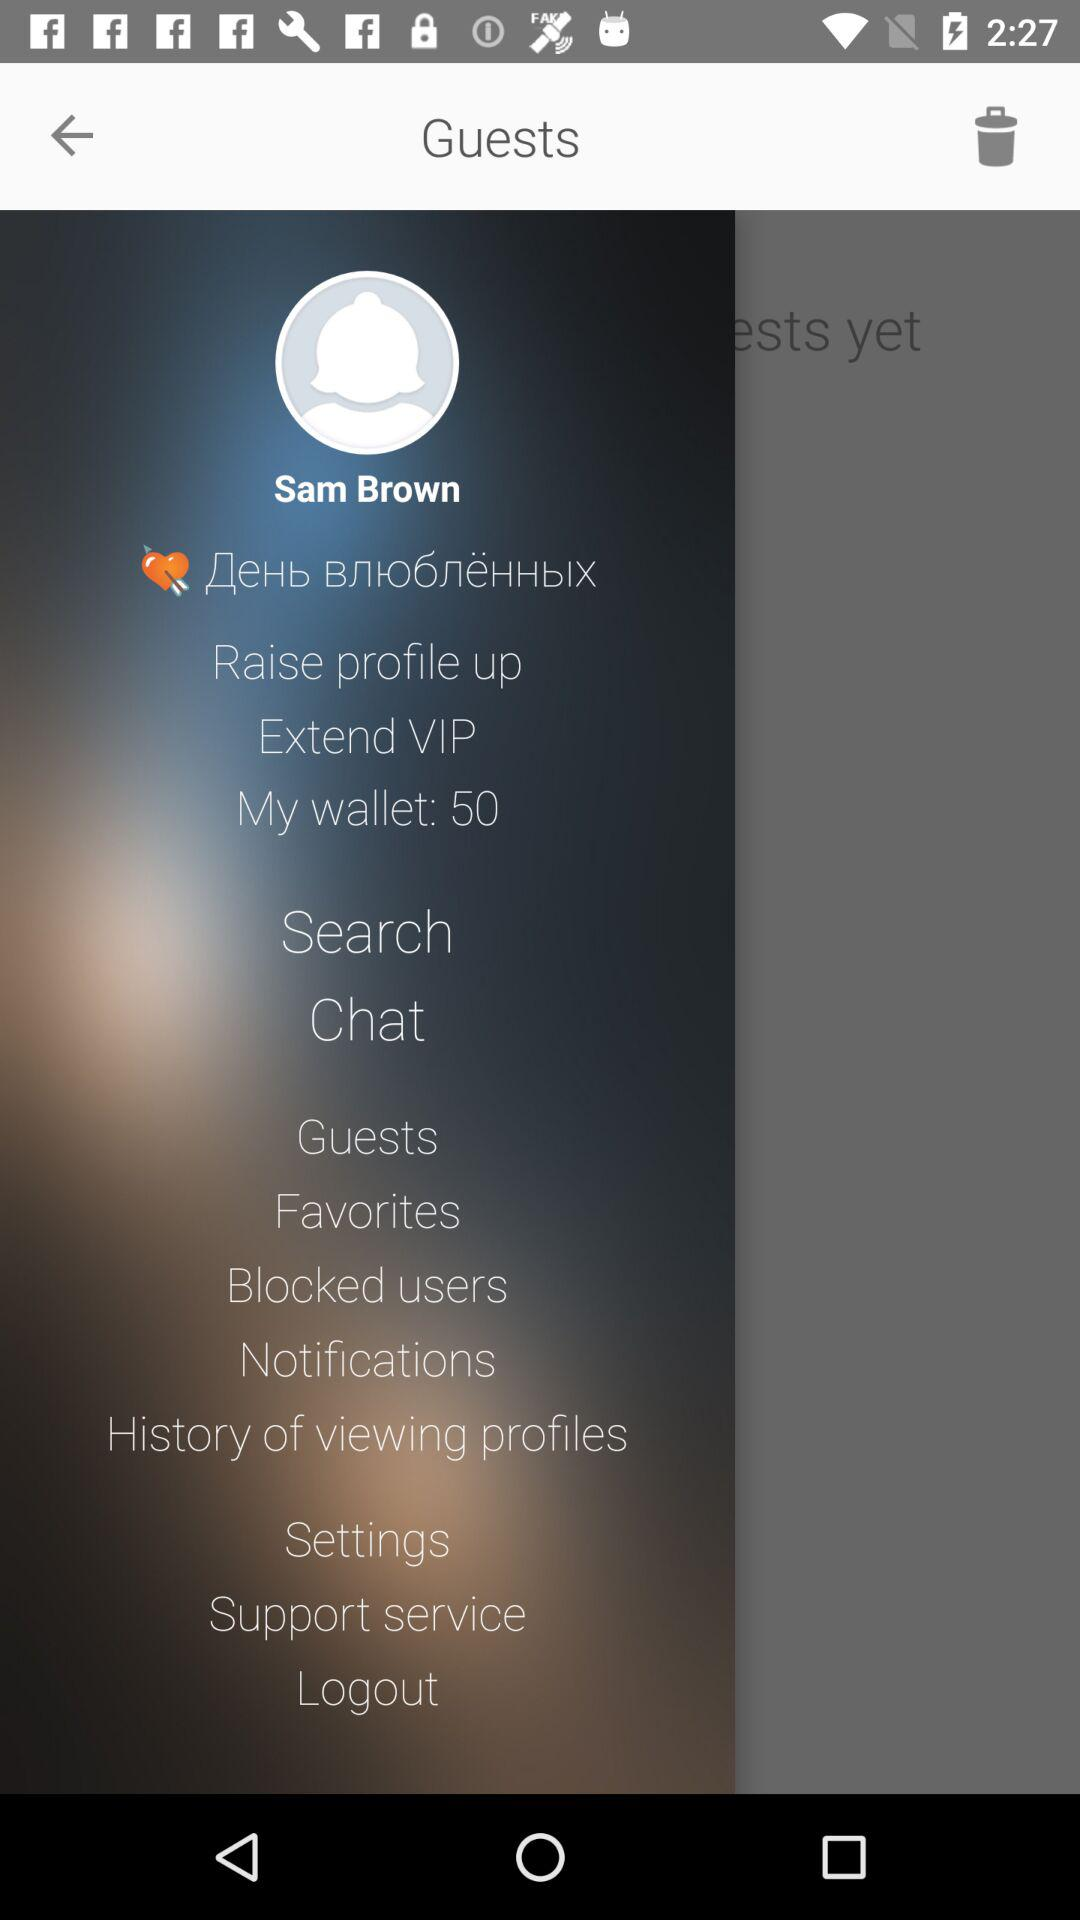Which users have been blocked?
When the provided information is insufficient, respond with <no answer>. <no answer> 